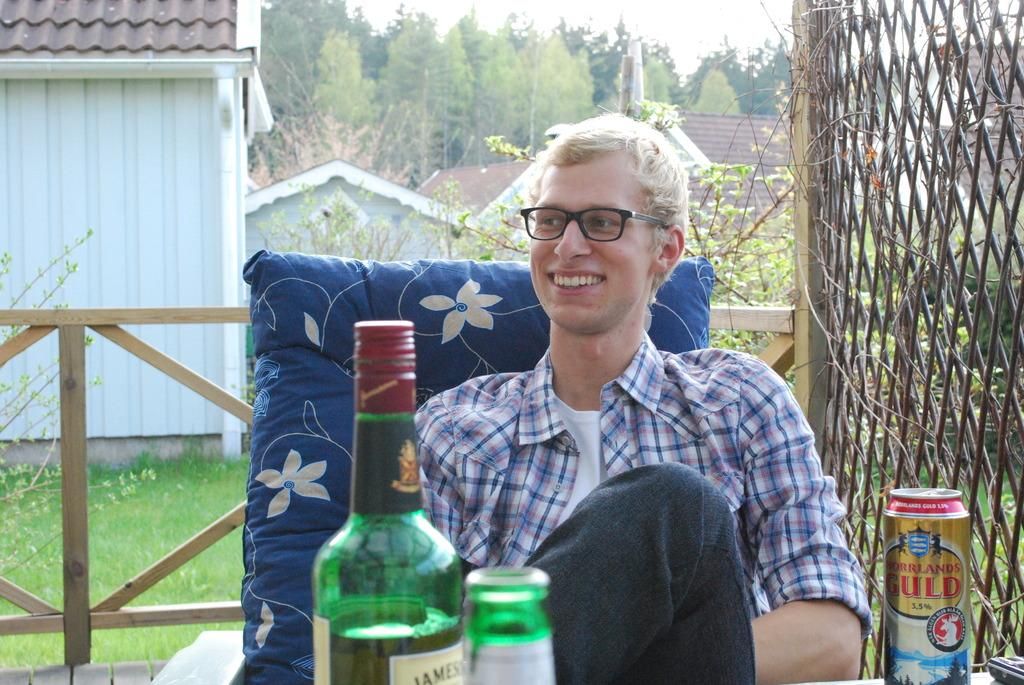What is the man in the image doing? There is a man sitting in the image. What object can be seen beside the man? There is a bottle in the image. What can be seen in the distance in the image? There is a house and trees in the background of the image. What is the name of the carriage in the image? There is no carriage present in the image. 